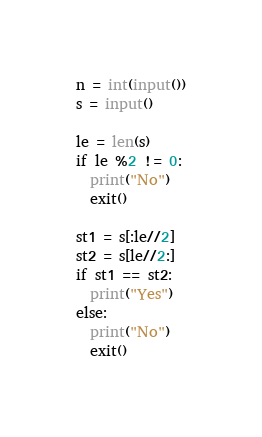Convert code to text. <code><loc_0><loc_0><loc_500><loc_500><_Python_>n = int(input())
s = input()

le = len(s)
if le %2 != 0:
  print("No")
  exit()

st1 = s[:le//2]
st2 = s[le//2:]
if st1 == st2:
  print("Yes")
else:
  print("No")
  exit()
</code> 